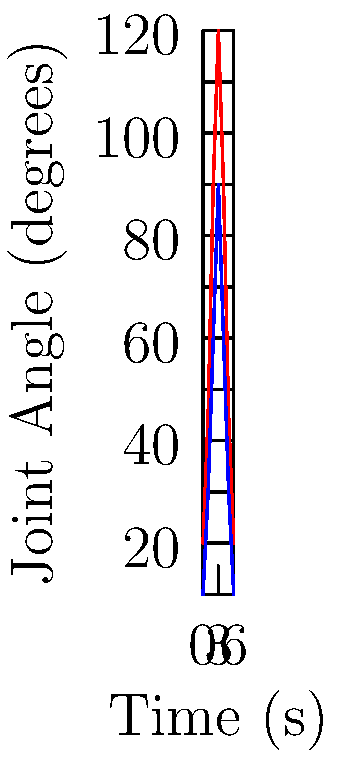In the context of Native American dance movements, analyze the joint angle graph provided. Which phase of the dance movement corresponds to the maximum flexion of both the knee and hip joints, and what might this represent in terms of traditional dance posture? To answer this question, we need to analyze the graph and interpret it in the context of Native American dance movements:

1. The graph shows two lines: red for the knee joint and blue for the hip joint.
2. The x-axis represents time in seconds, while the y-axis shows joint angles in degrees.
3. Both lines follow a similar pattern, peaking around the middle of the time frame.
4. The maximum flexion for both joints occurs at t = 3 seconds:
   - Knee angle reaches 120 degrees
   - Hip angle reaches 90 degrees
5. In biomechanics, larger joint angles typically indicate greater flexion.
6. This simultaneous peak flexion of both knee and hip joints likely represents a deep squat or crouching position.
7. In many Native American dances, such as the Ghost Dance or certain Pueblo dances, a low, grounded stance is common.
8. This posture often symbolizes connection to the earth or mimics animal movements in storytelling dances.
9. The gradual increase and decrease in joint angles before and after the peak suggest a controlled, rhythmic movement typical in traditional dances.

Therefore, the maximum flexion at t = 3 seconds likely represents a significant moment in the dance, possibly a deep, grounded stance that connects the dancer to the earth or embodies a specific animal or spirit being portrayed in the dance.
Answer: t = 3 seconds; represents a deep, grounded stance 